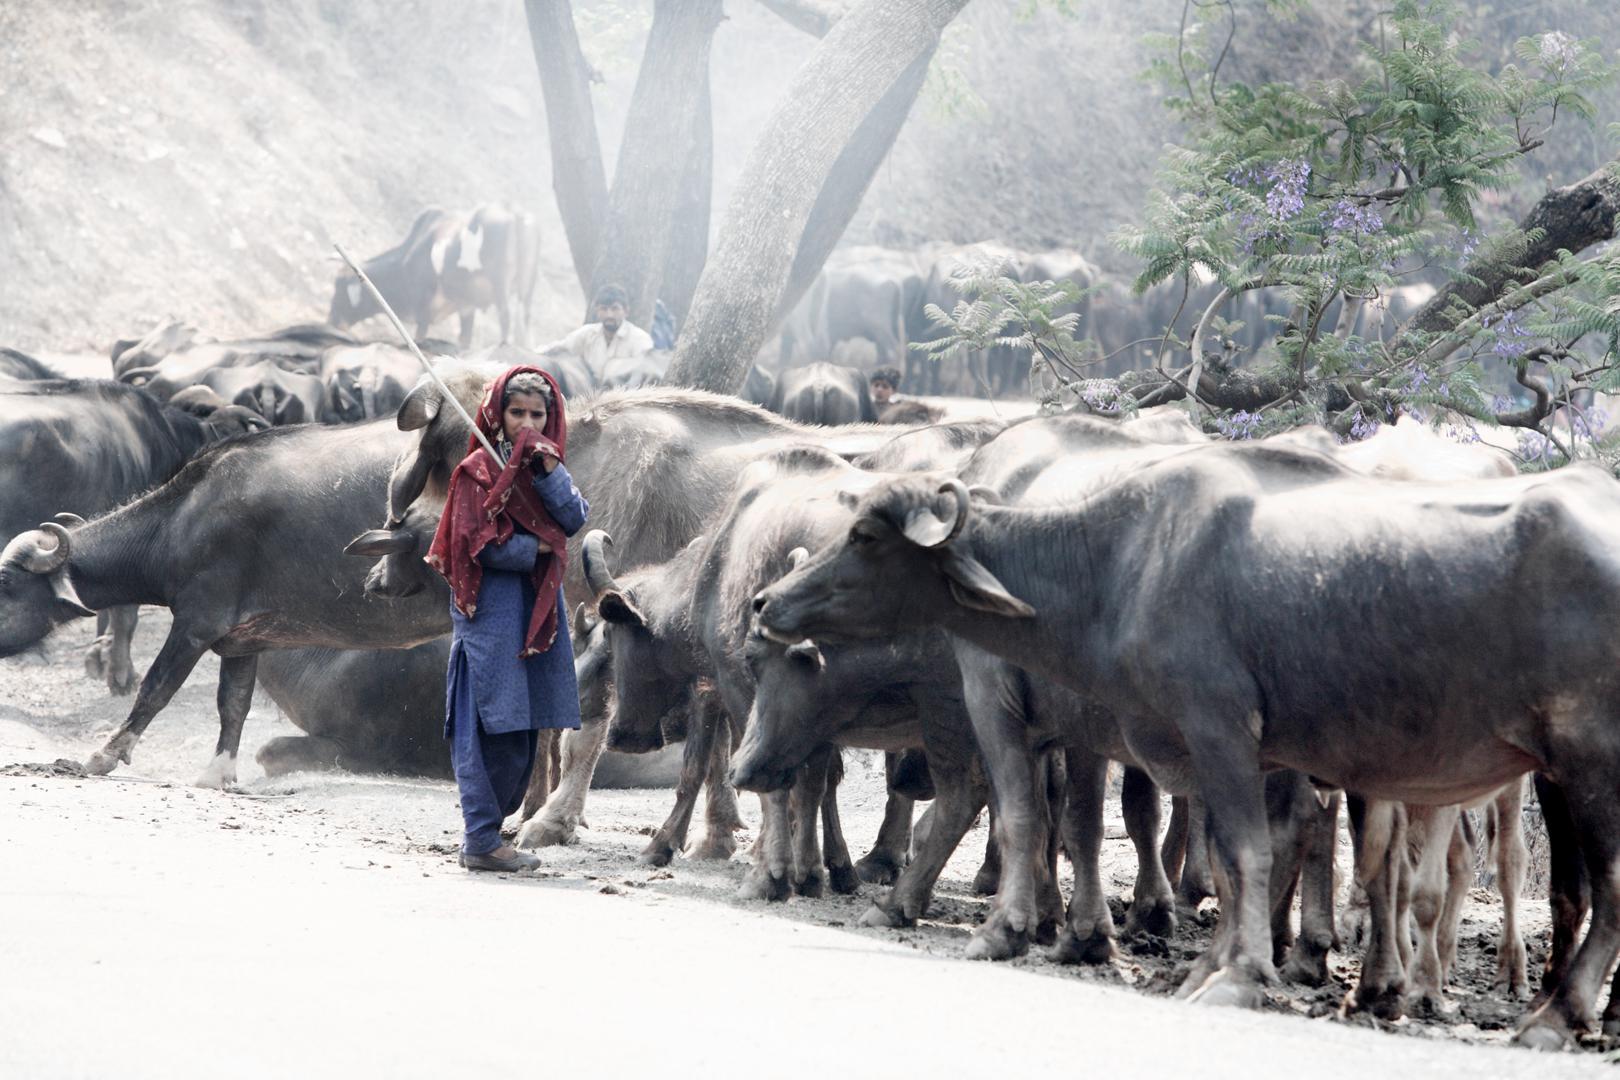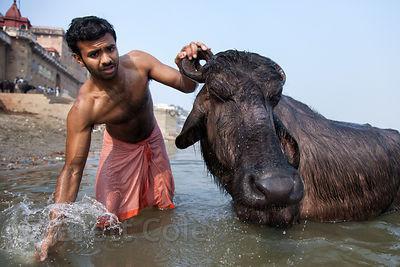The first image is the image on the left, the second image is the image on the right. Analyze the images presented: Is the assertion "One image includes a person standing by a water buffalo in a wet area, and the other image shows one person in blue standing by water buffalo on dry ground." valid? Answer yes or no. Yes. The first image is the image on the left, the second image is the image on the right. Evaluate the accuracy of this statement regarding the images: "In at least one image there is a single man with short hair to the left of a horned ox.". Is it true? Answer yes or no. Yes. 